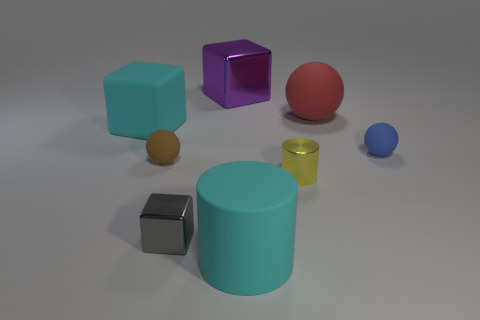Is the number of cyan matte blocks greater than the number of small red rubber spheres?
Provide a succinct answer. Yes. There is a metal thing right of the large cylinder; what is its shape?
Keep it short and to the point. Cylinder. What number of other matte objects are the same shape as the tiny yellow thing?
Offer a very short reply. 1. How big is the cyan thing that is right of the big block that is on the right side of the big rubber cube?
Provide a succinct answer. Large. What number of yellow objects are either rubber blocks or metal cylinders?
Give a very brief answer. 1. Is the number of small blue balls that are to the right of the small brown rubber ball less than the number of small metallic things in front of the blue sphere?
Provide a short and direct response. Yes. Do the rubber cylinder and the red rubber ball that is in front of the large metallic block have the same size?
Your response must be concise. Yes. How many cubes have the same size as the yellow thing?
Keep it short and to the point. 1. How many big objects are blue rubber spheres or brown metallic spheres?
Provide a short and direct response. 0. Are any big gray rubber cubes visible?
Offer a terse response. No. 